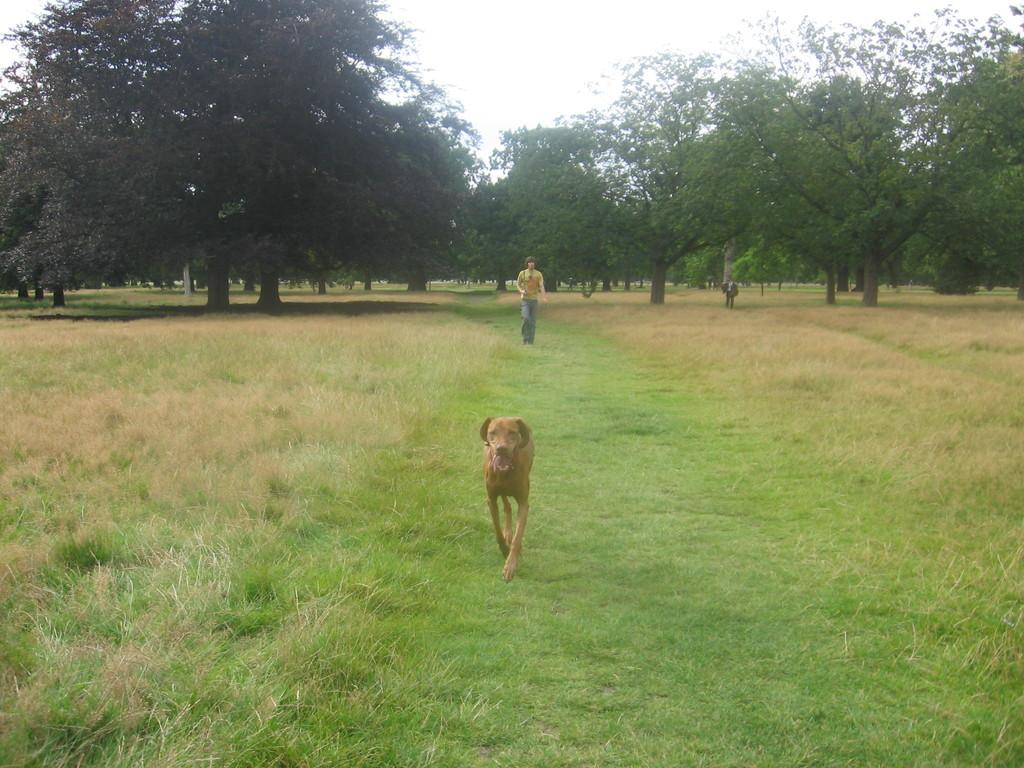What type of animal can be seen in the image? There is a brown color dog in the image. What is happening in the background of the image? There is a person walking in the background. What type of vegetation is present in the image? There are green trees and grass in the image. What is visible in the sky in the image? The sky is visible in the image, and its color is described as white. What type of string is being used to hold the wax in the image? There is no string or wax present in the image. How is the oatmeal being prepared in the image? There is no oatmeal present in the image. 